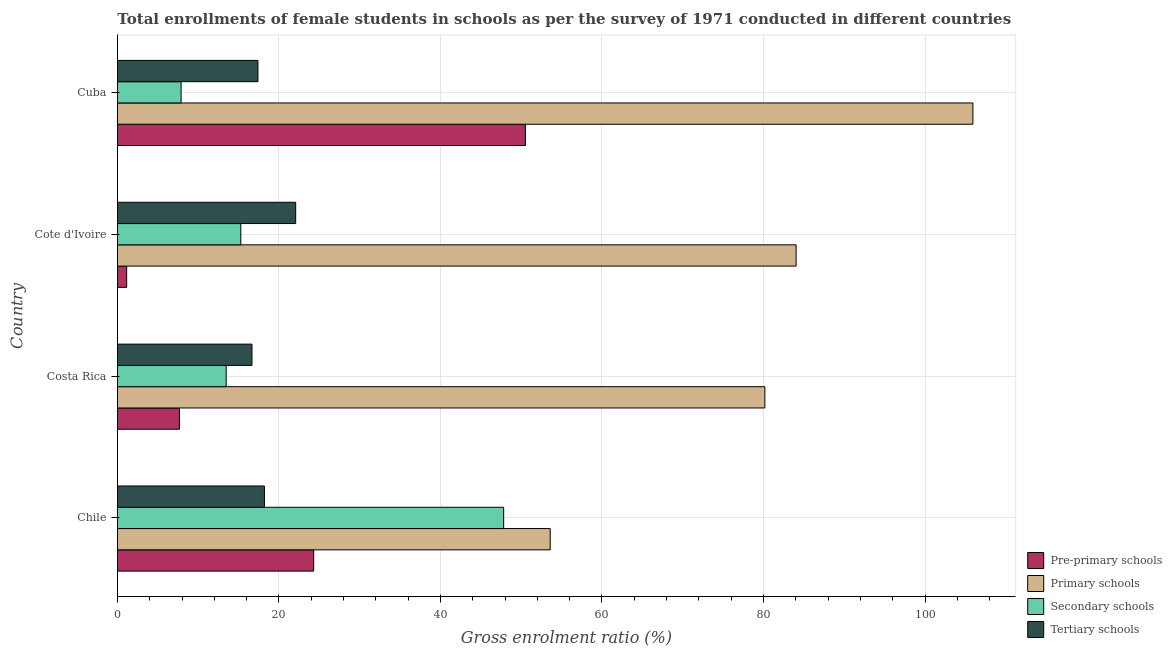How many different coloured bars are there?
Keep it short and to the point. 4. How many groups of bars are there?
Your answer should be compact. 4. How many bars are there on the 4th tick from the top?
Provide a short and direct response. 4. What is the label of the 1st group of bars from the top?
Offer a terse response. Cuba. In how many cases, is the number of bars for a given country not equal to the number of legend labels?
Give a very brief answer. 0. What is the gross enrolment ratio(female) in primary schools in Costa Rica?
Give a very brief answer. 80.17. Across all countries, what is the maximum gross enrolment ratio(female) in primary schools?
Provide a succinct answer. 105.93. Across all countries, what is the minimum gross enrolment ratio(female) in tertiary schools?
Your answer should be very brief. 16.66. In which country was the gross enrolment ratio(female) in primary schools maximum?
Your response must be concise. Cuba. What is the total gross enrolment ratio(female) in pre-primary schools in the graph?
Ensure brevity in your answer.  83.66. What is the difference between the gross enrolment ratio(female) in secondary schools in Costa Rica and that in Cote d'Ivoire?
Provide a short and direct response. -1.81. What is the difference between the gross enrolment ratio(female) in primary schools in Costa Rica and the gross enrolment ratio(female) in tertiary schools in Cote d'Ivoire?
Make the answer very short. 58.1. What is the average gross enrolment ratio(female) in secondary schools per country?
Keep it short and to the point. 21.11. What is the difference between the gross enrolment ratio(female) in primary schools and gross enrolment ratio(female) in pre-primary schools in Chile?
Offer a terse response. 29.29. In how many countries, is the gross enrolment ratio(female) in pre-primary schools greater than 84 %?
Provide a succinct answer. 0. What is the ratio of the gross enrolment ratio(female) in tertiary schools in Chile to that in Costa Rica?
Your answer should be compact. 1.09. Is the difference between the gross enrolment ratio(female) in secondary schools in Costa Rica and Cuba greater than the difference between the gross enrolment ratio(female) in pre-primary schools in Costa Rica and Cuba?
Your response must be concise. Yes. What is the difference between the highest and the second highest gross enrolment ratio(female) in pre-primary schools?
Provide a short and direct response. 26.21. What is the difference between the highest and the lowest gross enrolment ratio(female) in primary schools?
Your response must be concise. 52.34. In how many countries, is the gross enrolment ratio(female) in tertiary schools greater than the average gross enrolment ratio(female) in tertiary schools taken over all countries?
Offer a terse response. 1. Is the sum of the gross enrolment ratio(female) in tertiary schools in Costa Rica and Cuba greater than the maximum gross enrolment ratio(female) in pre-primary schools across all countries?
Give a very brief answer. No. What does the 4th bar from the top in Cuba represents?
Give a very brief answer. Pre-primary schools. What does the 2nd bar from the bottom in Cote d'Ivoire represents?
Your answer should be compact. Primary schools. Is it the case that in every country, the sum of the gross enrolment ratio(female) in pre-primary schools and gross enrolment ratio(female) in primary schools is greater than the gross enrolment ratio(female) in secondary schools?
Ensure brevity in your answer.  Yes. How many bars are there?
Make the answer very short. 16. Are all the bars in the graph horizontal?
Your response must be concise. Yes. How many countries are there in the graph?
Ensure brevity in your answer.  4. Does the graph contain any zero values?
Your answer should be very brief. No. Does the graph contain grids?
Give a very brief answer. Yes. Where does the legend appear in the graph?
Offer a terse response. Bottom right. How many legend labels are there?
Provide a succinct answer. 4. How are the legend labels stacked?
Provide a short and direct response. Vertical. What is the title of the graph?
Give a very brief answer. Total enrollments of female students in schools as per the survey of 1971 conducted in different countries. What is the label or title of the X-axis?
Make the answer very short. Gross enrolment ratio (%). What is the label or title of the Y-axis?
Ensure brevity in your answer.  Country. What is the Gross enrolment ratio (%) in Pre-primary schools in Chile?
Keep it short and to the point. 24.3. What is the Gross enrolment ratio (%) of Primary schools in Chile?
Provide a short and direct response. 53.59. What is the Gross enrolment ratio (%) in Secondary schools in Chile?
Your answer should be very brief. 47.83. What is the Gross enrolment ratio (%) of Tertiary schools in Chile?
Offer a terse response. 18.21. What is the Gross enrolment ratio (%) of Pre-primary schools in Costa Rica?
Offer a terse response. 7.69. What is the Gross enrolment ratio (%) of Primary schools in Costa Rica?
Offer a terse response. 80.17. What is the Gross enrolment ratio (%) of Secondary schools in Costa Rica?
Provide a succinct answer. 13.47. What is the Gross enrolment ratio (%) of Tertiary schools in Costa Rica?
Provide a short and direct response. 16.66. What is the Gross enrolment ratio (%) of Pre-primary schools in Cote d'Ivoire?
Provide a succinct answer. 1.15. What is the Gross enrolment ratio (%) of Primary schools in Cote d'Ivoire?
Provide a short and direct response. 84.04. What is the Gross enrolment ratio (%) of Secondary schools in Cote d'Ivoire?
Provide a short and direct response. 15.28. What is the Gross enrolment ratio (%) of Tertiary schools in Cote d'Ivoire?
Make the answer very short. 22.07. What is the Gross enrolment ratio (%) of Pre-primary schools in Cuba?
Offer a very short reply. 50.52. What is the Gross enrolment ratio (%) of Primary schools in Cuba?
Your answer should be compact. 105.93. What is the Gross enrolment ratio (%) of Secondary schools in Cuba?
Offer a terse response. 7.89. What is the Gross enrolment ratio (%) of Tertiary schools in Cuba?
Make the answer very short. 17.4. Across all countries, what is the maximum Gross enrolment ratio (%) in Pre-primary schools?
Your answer should be very brief. 50.52. Across all countries, what is the maximum Gross enrolment ratio (%) of Primary schools?
Provide a short and direct response. 105.93. Across all countries, what is the maximum Gross enrolment ratio (%) in Secondary schools?
Offer a terse response. 47.83. Across all countries, what is the maximum Gross enrolment ratio (%) in Tertiary schools?
Your answer should be compact. 22.07. Across all countries, what is the minimum Gross enrolment ratio (%) of Pre-primary schools?
Offer a very short reply. 1.15. Across all countries, what is the minimum Gross enrolment ratio (%) of Primary schools?
Give a very brief answer. 53.59. Across all countries, what is the minimum Gross enrolment ratio (%) of Secondary schools?
Ensure brevity in your answer.  7.89. Across all countries, what is the minimum Gross enrolment ratio (%) in Tertiary schools?
Your response must be concise. 16.66. What is the total Gross enrolment ratio (%) in Pre-primary schools in the graph?
Provide a succinct answer. 83.66. What is the total Gross enrolment ratio (%) of Primary schools in the graph?
Your answer should be very brief. 323.73. What is the total Gross enrolment ratio (%) of Secondary schools in the graph?
Ensure brevity in your answer.  84.46. What is the total Gross enrolment ratio (%) of Tertiary schools in the graph?
Your answer should be compact. 74.34. What is the difference between the Gross enrolment ratio (%) in Pre-primary schools in Chile and that in Costa Rica?
Keep it short and to the point. 16.62. What is the difference between the Gross enrolment ratio (%) in Primary schools in Chile and that in Costa Rica?
Provide a succinct answer. -26.58. What is the difference between the Gross enrolment ratio (%) in Secondary schools in Chile and that in Costa Rica?
Make the answer very short. 34.36. What is the difference between the Gross enrolment ratio (%) in Tertiary schools in Chile and that in Costa Rica?
Ensure brevity in your answer.  1.54. What is the difference between the Gross enrolment ratio (%) in Pre-primary schools in Chile and that in Cote d'Ivoire?
Keep it short and to the point. 23.16. What is the difference between the Gross enrolment ratio (%) of Primary schools in Chile and that in Cote d'Ivoire?
Your answer should be compact. -30.45. What is the difference between the Gross enrolment ratio (%) of Secondary schools in Chile and that in Cote d'Ivoire?
Give a very brief answer. 32.55. What is the difference between the Gross enrolment ratio (%) in Tertiary schools in Chile and that in Cote d'Ivoire?
Your answer should be very brief. -3.87. What is the difference between the Gross enrolment ratio (%) of Pre-primary schools in Chile and that in Cuba?
Offer a very short reply. -26.22. What is the difference between the Gross enrolment ratio (%) of Primary schools in Chile and that in Cuba?
Your response must be concise. -52.34. What is the difference between the Gross enrolment ratio (%) in Secondary schools in Chile and that in Cuba?
Ensure brevity in your answer.  39.94. What is the difference between the Gross enrolment ratio (%) in Tertiary schools in Chile and that in Cuba?
Make the answer very short. 0.81. What is the difference between the Gross enrolment ratio (%) of Pre-primary schools in Costa Rica and that in Cote d'Ivoire?
Keep it short and to the point. 6.54. What is the difference between the Gross enrolment ratio (%) in Primary schools in Costa Rica and that in Cote d'Ivoire?
Provide a short and direct response. -3.87. What is the difference between the Gross enrolment ratio (%) in Secondary schools in Costa Rica and that in Cote d'Ivoire?
Your answer should be very brief. -1.81. What is the difference between the Gross enrolment ratio (%) of Tertiary schools in Costa Rica and that in Cote d'Ivoire?
Ensure brevity in your answer.  -5.41. What is the difference between the Gross enrolment ratio (%) of Pre-primary schools in Costa Rica and that in Cuba?
Your answer should be very brief. -42.83. What is the difference between the Gross enrolment ratio (%) of Primary schools in Costa Rica and that in Cuba?
Give a very brief answer. -25.76. What is the difference between the Gross enrolment ratio (%) in Secondary schools in Costa Rica and that in Cuba?
Provide a short and direct response. 5.58. What is the difference between the Gross enrolment ratio (%) in Tertiary schools in Costa Rica and that in Cuba?
Offer a terse response. -0.74. What is the difference between the Gross enrolment ratio (%) of Pre-primary schools in Cote d'Ivoire and that in Cuba?
Ensure brevity in your answer.  -49.37. What is the difference between the Gross enrolment ratio (%) in Primary schools in Cote d'Ivoire and that in Cuba?
Your response must be concise. -21.89. What is the difference between the Gross enrolment ratio (%) of Secondary schools in Cote d'Ivoire and that in Cuba?
Offer a very short reply. 7.39. What is the difference between the Gross enrolment ratio (%) of Tertiary schools in Cote d'Ivoire and that in Cuba?
Your answer should be compact. 4.67. What is the difference between the Gross enrolment ratio (%) in Pre-primary schools in Chile and the Gross enrolment ratio (%) in Primary schools in Costa Rica?
Provide a succinct answer. -55.87. What is the difference between the Gross enrolment ratio (%) in Pre-primary schools in Chile and the Gross enrolment ratio (%) in Secondary schools in Costa Rica?
Keep it short and to the point. 10.84. What is the difference between the Gross enrolment ratio (%) in Pre-primary schools in Chile and the Gross enrolment ratio (%) in Tertiary schools in Costa Rica?
Offer a terse response. 7.64. What is the difference between the Gross enrolment ratio (%) of Primary schools in Chile and the Gross enrolment ratio (%) of Secondary schools in Costa Rica?
Give a very brief answer. 40.13. What is the difference between the Gross enrolment ratio (%) of Primary schools in Chile and the Gross enrolment ratio (%) of Tertiary schools in Costa Rica?
Offer a terse response. 36.93. What is the difference between the Gross enrolment ratio (%) in Secondary schools in Chile and the Gross enrolment ratio (%) in Tertiary schools in Costa Rica?
Ensure brevity in your answer.  31.16. What is the difference between the Gross enrolment ratio (%) of Pre-primary schools in Chile and the Gross enrolment ratio (%) of Primary schools in Cote d'Ivoire?
Your answer should be very brief. -59.74. What is the difference between the Gross enrolment ratio (%) of Pre-primary schools in Chile and the Gross enrolment ratio (%) of Secondary schools in Cote d'Ivoire?
Your answer should be very brief. 9.03. What is the difference between the Gross enrolment ratio (%) in Pre-primary schools in Chile and the Gross enrolment ratio (%) in Tertiary schools in Cote d'Ivoire?
Provide a short and direct response. 2.23. What is the difference between the Gross enrolment ratio (%) in Primary schools in Chile and the Gross enrolment ratio (%) in Secondary schools in Cote d'Ivoire?
Offer a terse response. 38.31. What is the difference between the Gross enrolment ratio (%) of Primary schools in Chile and the Gross enrolment ratio (%) of Tertiary schools in Cote d'Ivoire?
Ensure brevity in your answer.  31.52. What is the difference between the Gross enrolment ratio (%) of Secondary schools in Chile and the Gross enrolment ratio (%) of Tertiary schools in Cote d'Ivoire?
Make the answer very short. 25.75. What is the difference between the Gross enrolment ratio (%) in Pre-primary schools in Chile and the Gross enrolment ratio (%) in Primary schools in Cuba?
Your response must be concise. -81.63. What is the difference between the Gross enrolment ratio (%) of Pre-primary schools in Chile and the Gross enrolment ratio (%) of Secondary schools in Cuba?
Your answer should be very brief. 16.42. What is the difference between the Gross enrolment ratio (%) in Pre-primary schools in Chile and the Gross enrolment ratio (%) in Tertiary schools in Cuba?
Provide a short and direct response. 6.9. What is the difference between the Gross enrolment ratio (%) of Primary schools in Chile and the Gross enrolment ratio (%) of Secondary schools in Cuba?
Make the answer very short. 45.7. What is the difference between the Gross enrolment ratio (%) of Primary schools in Chile and the Gross enrolment ratio (%) of Tertiary schools in Cuba?
Provide a succinct answer. 36.19. What is the difference between the Gross enrolment ratio (%) in Secondary schools in Chile and the Gross enrolment ratio (%) in Tertiary schools in Cuba?
Ensure brevity in your answer.  30.43. What is the difference between the Gross enrolment ratio (%) in Pre-primary schools in Costa Rica and the Gross enrolment ratio (%) in Primary schools in Cote d'Ivoire?
Your response must be concise. -76.36. What is the difference between the Gross enrolment ratio (%) of Pre-primary schools in Costa Rica and the Gross enrolment ratio (%) of Secondary schools in Cote d'Ivoire?
Make the answer very short. -7.59. What is the difference between the Gross enrolment ratio (%) in Pre-primary schools in Costa Rica and the Gross enrolment ratio (%) in Tertiary schools in Cote d'Ivoire?
Offer a terse response. -14.39. What is the difference between the Gross enrolment ratio (%) in Primary schools in Costa Rica and the Gross enrolment ratio (%) in Secondary schools in Cote d'Ivoire?
Offer a very short reply. 64.89. What is the difference between the Gross enrolment ratio (%) in Primary schools in Costa Rica and the Gross enrolment ratio (%) in Tertiary schools in Cote d'Ivoire?
Your response must be concise. 58.1. What is the difference between the Gross enrolment ratio (%) in Secondary schools in Costa Rica and the Gross enrolment ratio (%) in Tertiary schools in Cote d'Ivoire?
Ensure brevity in your answer.  -8.61. What is the difference between the Gross enrolment ratio (%) in Pre-primary schools in Costa Rica and the Gross enrolment ratio (%) in Primary schools in Cuba?
Offer a terse response. -98.25. What is the difference between the Gross enrolment ratio (%) in Pre-primary schools in Costa Rica and the Gross enrolment ratio (%) in Secondary schools in Cuba?
Provide a succinct answer. -0.2. What is the difference between the Gross enrolment ratio (%) in Pre-primary schools in Costa Rica and the Gross enrolment ratio (%) in Tertiary schools in Cuba?
Keep it short and to the point. -9.72. What is the difference between the Gross enrolment ratio (%) in Primary schools in Costa Rica and the Gross enrolment ratio (%) in Secondary schools in Cuba?
Keep it short and to the point. 72.28. What is the difference between the Gross enrolment ratio (%) in Primary schools in Costa Rica and the Gross enrolment ratio (%) in Tertiary schools in Cuba?
Your answer should be very brief. 62.77. What is the difference between the Gross enrolment ratio (%) in Secondary schools in Costa Rica and the Gross enrolment ratio (%) in Tertiary schools in Cuba?
Your answer should be very brief. -3.94. What is the difference between the Gross enrolment ratio (%) of Pre-primary schools in Cote d'Ivoire and the Gross enrolment ratio (%) of Primary schools in Cuba?
Provide a short and direct response. -104.78. What is the difference between the Gross enrolment ratio (%) in Pre-primary schools in Cote d'Ivoire and the Gross enrolment ratio (%) in Secondary schools in Cuba?
Provide a short and direct response. -6.74. What is the difference between the Gross enrolment ratio (%) in Pre-primary schools in Cote d'Ivoire and the Gross enrolment ratio (%) in Tertiary schools in Cuba?
Your response must be concise. -16.25. What is the difference between the Gross enrolment ratio (%) of Primary schools in Cote d'Ivoire and the Gross enrolment ratio (%) of Secondary schools in Cuba?
Make the answer very short. 76.15. What is the difference between the Gross enrolment ratio (%) of Primary schools in Cote d'Ivoire and the Gross enrolment ratio (%) of Tertiary schools in Cuba?
Provide a succinct answer. 66.64. What is the difference between the Gross enrolment ratio (%) of Secondary schools in Cote d'Ivoire and the Gross enrolment ratio (%) of Tertiary schools in Cuba?
Offer a terse response. -2.12. What is the average Gross enrolment ratio (%) of Pre-primary schools per country?
Your answer should be very brief. 20.91. What is the average Gross enrolment ratio (%) in Primary schools per country?
Offer a very short reply. 80.93. What is the average Gross enrolment ratio (%) in Secondary schools per country?
Offer a terse response. 21.11. What is the average Gross enrolment ratio (%) in Tertiary schools per country?
Make the answer very short. 18.59. What is the difference between the Gross enrolment ratio (%) of Pre-primary schools and Gross enrolment ratio (%) of Primary schools in Chile?
Your answer should be very brief. -29.29. What is the difference between the Gross enrolment ratio (%) in Pre-primary schools and Gross enrolment ratio (%) in Secondary schools in Chile?
Keep it short and to the point. -23.52. What is the difference between the Gross enrolment ratio (%) in Pre-primary schools and Gross enrolment ratio (%) in Tertiary schools in Chile?
Offer a terse response. 6.1. What is the difference between the Gross enrolment ratio (%) of Primary schools and Gross enrolment ratio (%) of Secondary schools in Chile?
Offer a very short reply. 5.76. What is the difference between the Gross enrolment ratio (%) of Primary schools and Gross enrolment ratio (%) of Tertiary schools in Chile?
Provide a short and direct response. 35.38. What is the difference between the Gross enrolment ratio (%) of Secondary schools and Gross enrolment ratio (%) of Tertiary schools in Chile?
Keep it short and to the point. 29.62. What is the difference between the Gross enrolment ratio (%) in Pre-primary schools and Gross enrolment ratio (%) in Primary schools in Costa Rica?
Provide a short and direct response. -72.48. What is the difference between the Gross enrolment ratio (%) in Pre-primary schools and Gross enrolment ratio (%) in Secondary schools in Costa Rica?
Provide a short and direct response. -5.78. What is the difference between the Gross enrolment ratio (%) in Pre-primary schools and Gross enrolment ratio (%) in Tertiary schools in Costa Rica?
Your answer should be very brief. -8.98. What is the difference between the Gross enrolment ratio (%) of Primary schools and Gross enrolment ratio (%) of Secondary schools in Costa Rica?
Your answer should be compact. 66.7. What is the difference between the Gross enrolment ratio (%) in Primary schools and Gross enrolment ratio (%) in Tertiary schools in Costa Rica?
Your response must be concise. 63.51. What is the difference between the Gross enrolment ratio (%) in Secondary schools and Gross enrolment ratio (%) in Tertiary schools in Costa Rica?
Ensure brevity in your answer.  -3.2. What is the difference between the Gross enrolment ratio (%) of Pre-primary schools and Gross enrolment ratio (%) of Primary schools in Cote d'Ivoire?
Provide a succinct answer. -82.89. What is the difference between the Gross enrolment ratio (%) of Pre-primary schools and Gross enrolment ratio (%) of Secondary schools in Cote d'Ivoire?
Your answer should be compact. -14.13. What is the difference between the Gross enrolment ratio (%) of Pre-primary schools and Gross enrolment ratio (%) of Tertiary schools in Cote d'Ivoire?
Your response must be concise. -20.92. What is the difference between the Gross enrolment ratio (%) in Primary schools and Gross enrolment ratio (%) in Secondary schools in Cote d'Ivoire?
Offer a terse response. 68.76. What is the difference between the Gross enrolment ratio (%) in Primary schools and Gross enrolment ratio (%) in Tertiary schools in Cote d'Ivoire?
Ensure brevity in your answer.  61.97. What is the difference between the Gross enrolment ratio (%) of Secondary schools and Gross enrolment ratio (%) of Tertiary schools in Cote d'Ivoire?
Provide a succinct answer. -6.8. What is the difference between the Gross enrolment ratio (%) in Pre-primary schools and Gross enrolment ratio (%) in Primary schools in Cuba?
Give a very brief answer. -55.41. What is the difference between the Gross enrolment ratio (%) of Pre-primary schools and Gross enrolment ratio (%) of Secondary schools in Cuba?
Your response must be concise. 42.63. What is the difference between the Gross enrolment ratio (%) of Pre-primary schools and Gross enrolment ratio (%) of Tertiary schools in Cuba?
Keep it short and to the point. 33.12. What is the difference between the Gross enrolment ratio (%) of Primary schools and Gross enrolment ratio (%) of Secondary schools in Cuba?
Offer a terse response. 98.05. What is the difference between the Gross enrolment ratio (%) in Primary schools and Gross enrolment ratio (%) in Tertiary schools in Cuba?
Provide a succinct answer. 88.53. What is the difference between the Gross enrolment ratio (%) of Secondary schools and Gross enrolment ratio (%) of Tertiary schools in Cuba?
Ensure brevity in your answer.  -9.51. What is the ratio of the Gross enrolment ratio (%) of Pre-primary schools in Chile to that in Costa Rica?
Give a very brief answer. 3.16. What is the ratio of the Gross enrolment ratio (%) of Primary schools in Chile to that in Costa Rica?
Ensure brevity in your answer.  0.67. What is the ratio of the Gross enrolment ratio (%) of Secondary schools in Chile to that in Costa Rica?
Provide a short and direct response. 3.55. What is the ratio of the Gross enrolment ratio (%) of Tertiary schools in Chile to that in Costa Rica?
Your answer should be very brief. 1.09. What is the ratio of the Gross enrolment ratio (%) in Pre-primary schools in Chile to that in Cote d'Ivoire?
Your answer should be compact. 21.16. What is the ratio of the Gross enrolment ratio (%) in Primary schools in Chile to that in Cote d'Ivoire?
Give a very brief answer. 0.64. What is the ratio of the Gross enrolment ratio (%) of Secondary schools in Chile to that in Cote d'Ivoire?
Provide a succinct answer. 3.13. What is the ratio of the Gross enrolment ratio (%) in Tertiary schools in Chile to that in Cote d'Ivoire?
Keep it short and to the point. 0.82. What is the ratio of the Gross enrolment ratio (%) of Pre-primary schools in Chile to that in Cuba?
Offer a very short reply. 0.48. What is the ratio of the Gross enrolment ratio (%) in Primary schools in Chile to that in Cuba?
Offer a very short reply. 0.51. What is the ratio of the Gross enrolment ratio (%) of Secondary schools in Chile to that in Cuba?
Your response must be concise. 6.06. What is the ratio of the Gross enrolment ratio (%) of Tertiary schools in Chile to that in Cuba?
Offer a terse response. 1.05. What is the ratio of the Gross enrolment ratio (%) of Pre-primary schools in Costa Rica to that in Cote d'Ivoire?
Give a very brief answer. 6.69. What is the ratio of the Gross enrolment ratio (%) of Primary schools in Costa Rica to that in Cote d'Ivoire?
Your response must be concise. 0.95. What is the ratio of the Gross enrolment ratio (%) of Secondary schools in Costa Rica to that in Cote d'Ivoire?
Provide a succinct answer. 0.88. What is the ratio of the Gross enrolment ratio (%) of Tertiary schools in Costa Rica to that in Cote d'Ivoire?
Make the answer very short. 0.75. What is the ratio of the Gross enrolment ratio (%) in Pre-primary schools in Costa Rica to that in Cuba?
Your response must be concise. 0.15. What is the ratio of the Gross enrolment ratio (%) in Primary schools in Costa Rica to that in Cuba?
Provide a succinct answer. 0.76. What is the ratio of the Gross enrolment ratio (%) in Secondary schools in Costa Rica to that in Cuba?
Your answer should be very brief. 1.71. What is the ratio of the Gross enrolment ratio (%) of Tertiary schools in Costa Rica to that in Cuba?
Make the answer very short. 0.96. What is the ratio of the Gross enrolment ratio (%) of Pre-primary schools in Cote d'Ivoire to that in Cuba?
Keep it short and to the point. 0.02. What is the ratio of the Gross enrolment ratio (%) of Primary schools in Cote d'Ivoire to that in Cuba?
Make the answer very short. 0.79. What is the ratio of the Gross enrolment ratio (%) in Secondary schools in Cote d'Ivoire to that in Cuba?
Keep it short and to the point. 1.94. What is the ratio of the Gross enrolment ratio (%) in Tertiary schools in Cote d'Ivoire to that in Cuba?
Offer a terse response. 1.27. What is the difference between the highest and the second highest Gross enrolment ratio (%) of Pre-primary schools?
Ensure brevity in your answer.  26.22. What is the difference between the highest and the second highest Gross enrolment ratio (%) in Primary schools?
Provide a succinct answer. 21.89. What is the difference between the highest and the second highest Gross enrolment ratio (%) of Secondary schools?
Your answer should be very brief. 32.55. What is the difference between the highest and the second highest Gross enrolment ratio (%) in Tertiary schools?
Offer a very short reply. 3.87. What is the difference between the highest and the lowest Gross enrolment ratio (%) in Pre-primary schools?
Offer a very short reply. 49.37. What is the difference between the highest and the lowest Gross enrolment ratio (%) of Primary schools?
Your response must be concise. 52.34. What is the difference between the highest and the lowest Gross enrolment ratio (%) in Secondary schools?
Your answer should be compact. 39.94. What is the difference between the highest and the lowest Gross enrolment ratio (%) in Tertiary schools?
Provide a succinct answer. 5.41. 